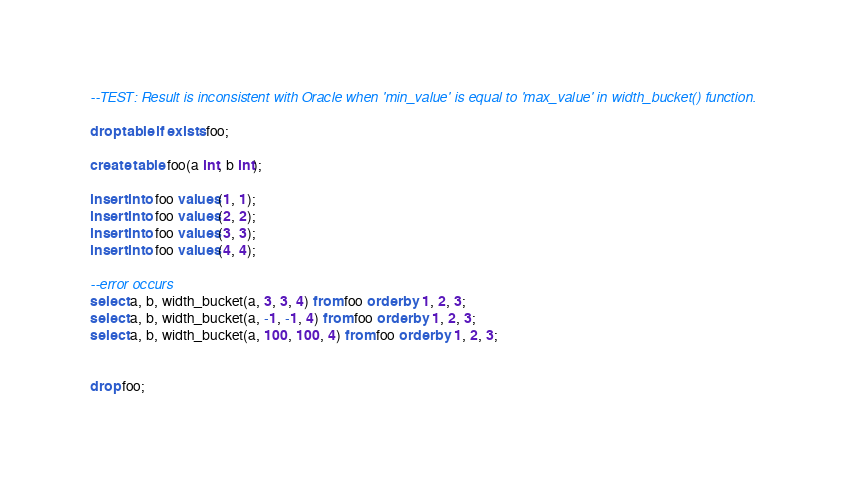<code> <loc_0><loc_0><loc_500><loc_500><_SQL_>--TEST: Result is inconsistent with Oracle when 'min_value' is equal to 'max_value' in width_bucket() function.

drop table if exists foo;

create table foo(a int, b int);

insert into foo values(1, 1);
insert into foo values(2, 2);
insert into foo values(3, 3);
insert into foo values(4, 4);

--error occurs
select a, b, width_bucket(a, 3, 3, 4) from foo order by 1, 2, 3;
select a, b, width_bucket(a, -1, -1, 4) from foo order by 1, 2, 3;
select a, b, width_bucket(a, 100, 100, 4) from foo order by 1, 2, 3;


drop foo;
</code> 